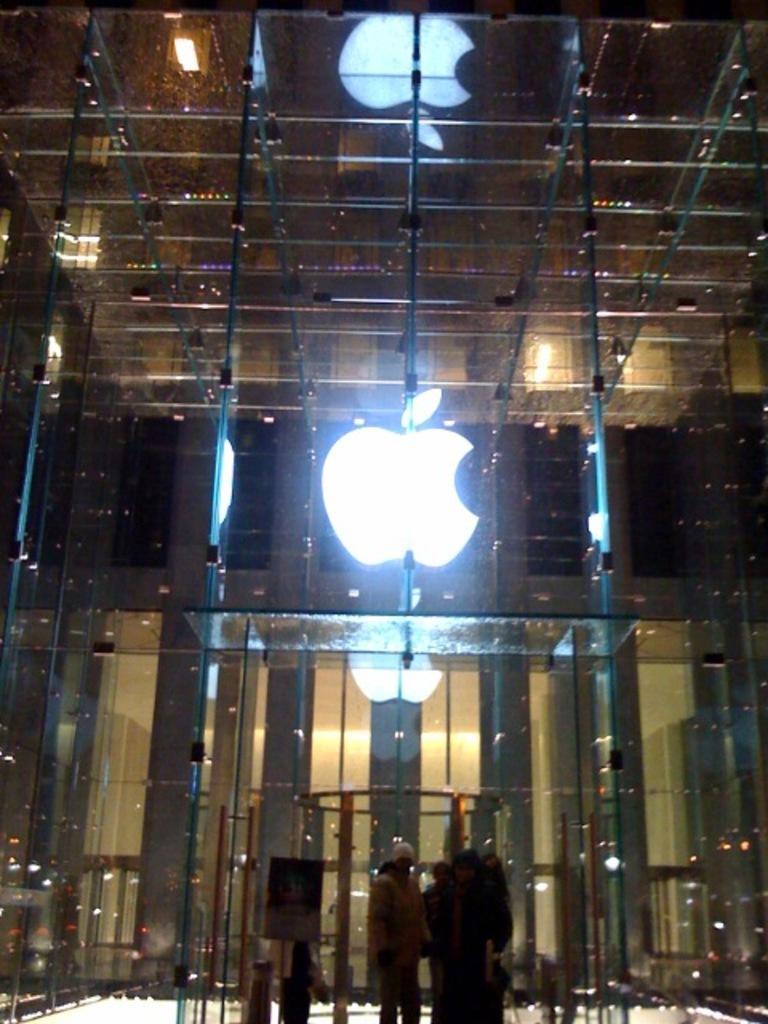What type of building is shown in the image? The image contains a building made of glass. Can you describe the people in the image? There are three persons standing at the bottom of the building. What else can be seen in the background of the image? There are lights visible in the background of the image. How many cherries are being eaten by the persons in the image? There are no cherries present in the image, so it cannot be determined how many might be eaten. What type of cast can be seen on the person's mouth in the image? There is no person with a cast on their mouth in the image. 